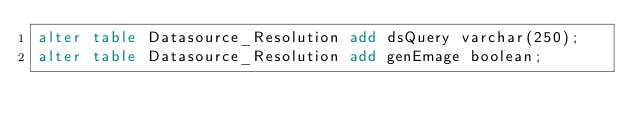<code> <loc_0><loc_0><loc_500><loc_500><_SQL_>alter table Datasource_Resolution add dsQuery varchar(250);
alter table Datasource_Resolution add genEmage boolean;
</code> 